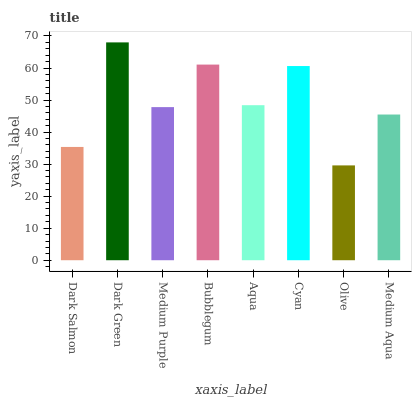Is Olive the minimum?
Answer yes or no. Yes. Is Dark Green the maximum?
Answer yes or no. Yes. Is Medium Purple the minimum?
Answer yes or no. No. Is Medium Purple the maximum?
Answer yes or no. No. Is Dark Green greater than Medium Purple?
Answer yes or no. Yes. Is Medium Purple less than Dark Green?
Answer yes or no. Yes. Is Medium Purple greater than Dark Green?
Answer yes or no. No. Is Dark Green less than Medium Purple?
Answer yes or no. No. Is Aqua the high median?
Answer yes or no. Yes. Is Medium Purple the low median?
Answer yes or no. Yes. Is Olive the high median?
Answer yes or no. No. Is Cyan the low median?
Answer yes or no. No. 